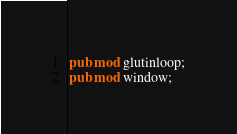Convert code to text. <code><loc_0><loc_0><loc_500><loc_500><_Rust_>pub mod glutinloop;
pub mod window;
</code> 